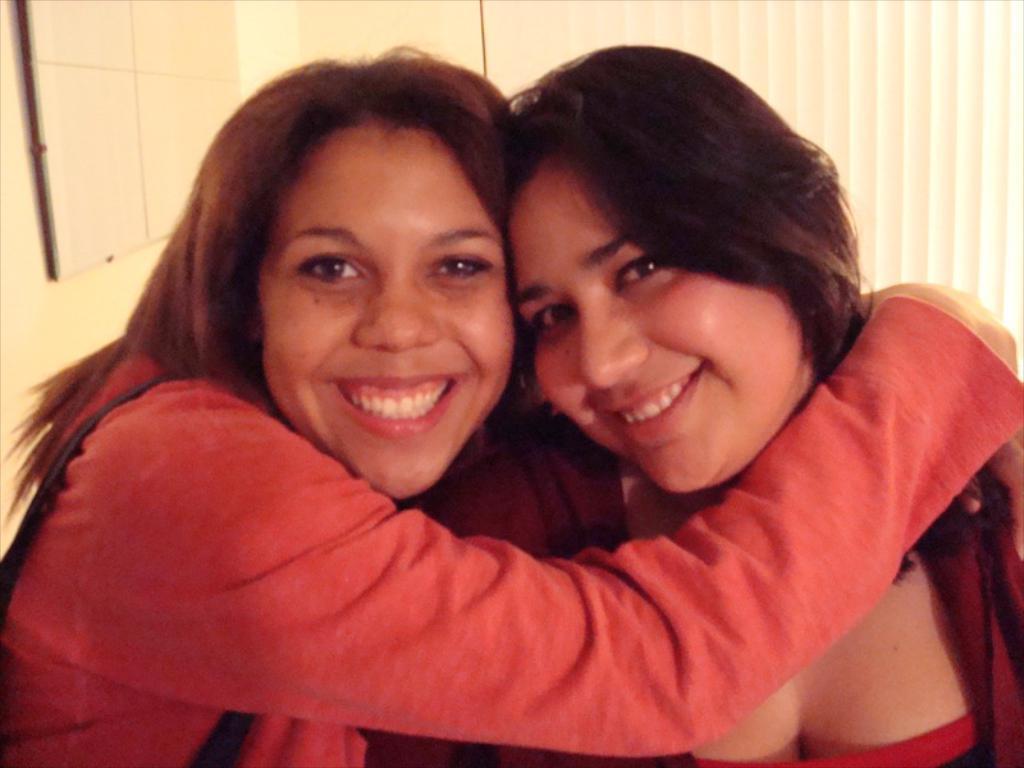How would you summarize this image in a sentence or two? In this image we can see two women holding each other. On the backside we can see a board on a wall. 